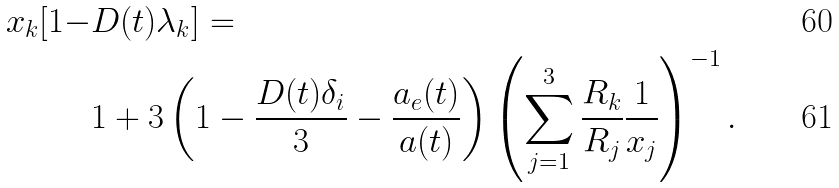<formula> <loc_0><loc_0><loc_500><loc_500>x _ { k } [ 1 - & D ( t ) \lambda _ { k } ] = \\ & 1 + 3 \left ( 1 - \frac { D ( t ) \delta _ { i } } { 3 } - \frac { a _ { e } ( t ) } { a ( t ) } \right ) \left ( \sum _ { j = 1 } ^ { 3 } \frac { R _ { k } } { R _ { j } } \frac { 1 } { x _ { j } } \right ) ^ { - 1 } .</formula> 